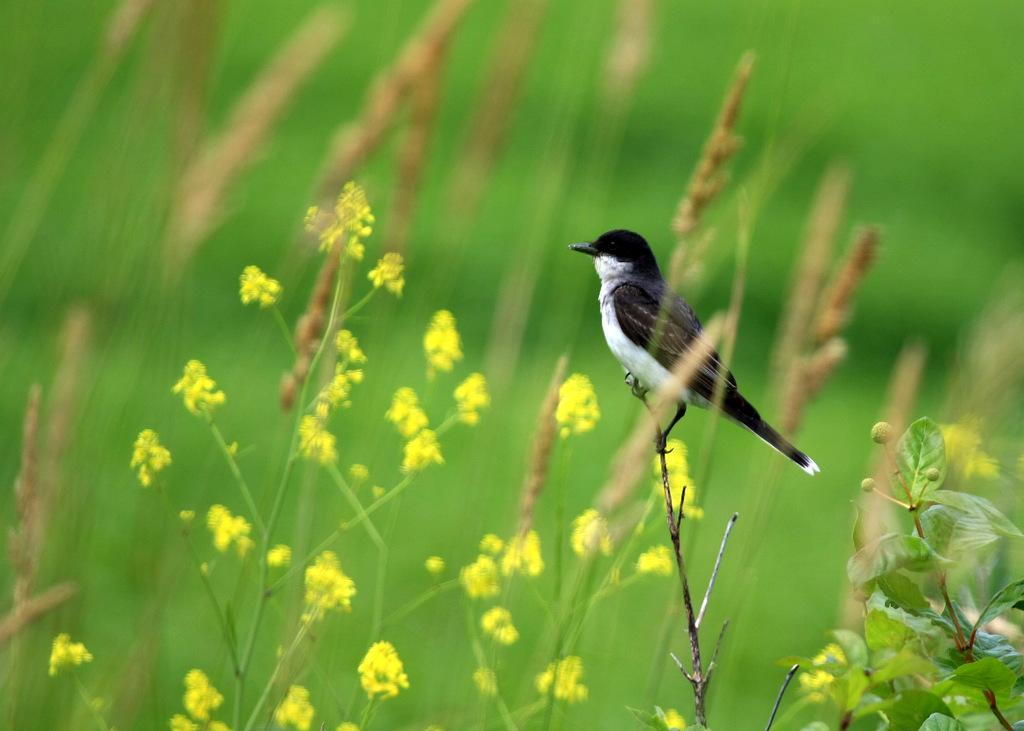What type of animal is in the image? There is a bird in the image. What is the bird standing on? The bird is standing on a stick. What type of vegetation is present in the image? There are flower plants and grass in the image. What type of frame surrounds the bird in the image? There is no frame surrounding the bird in the image; it is standing on a stick in an open environment. 